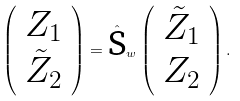<formula> <loc_0><loc_0><loc_500><loc_500>\left ( \begin{array} { c } Z _ { 1 } \\ \tilde { Z } _ { 2 } \end{array} \right ) = \hat { \text {S} } _ { w } \left ( \begin{array} { c } \tilde { Z } _ { 1 } \\ Z _ { 2 } \end{array} \right ) .</formula> 